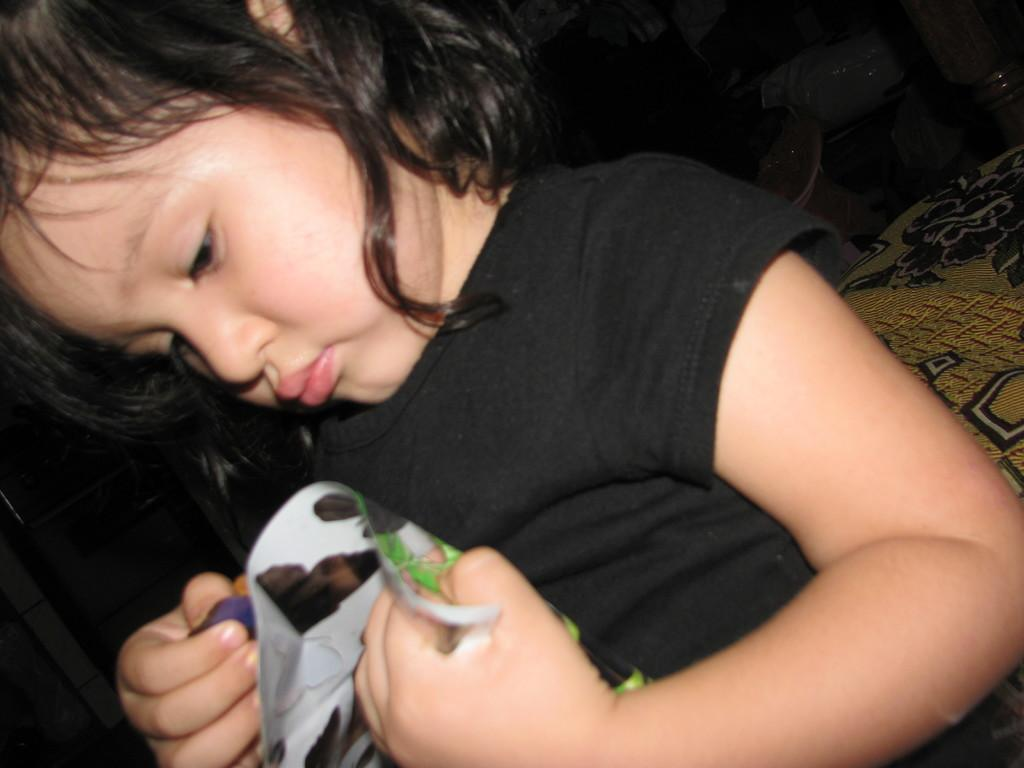What can be seen in the image? There is a person in the image. What is the person doing in the image? The person is holding an object. What is on the right side of the image? There is a cloth on the right side of the image. How would you describe the background of the image? The background of the image is dark. What type of silk is being used to create the cord in the image? There is no silk or cord present in the image. 